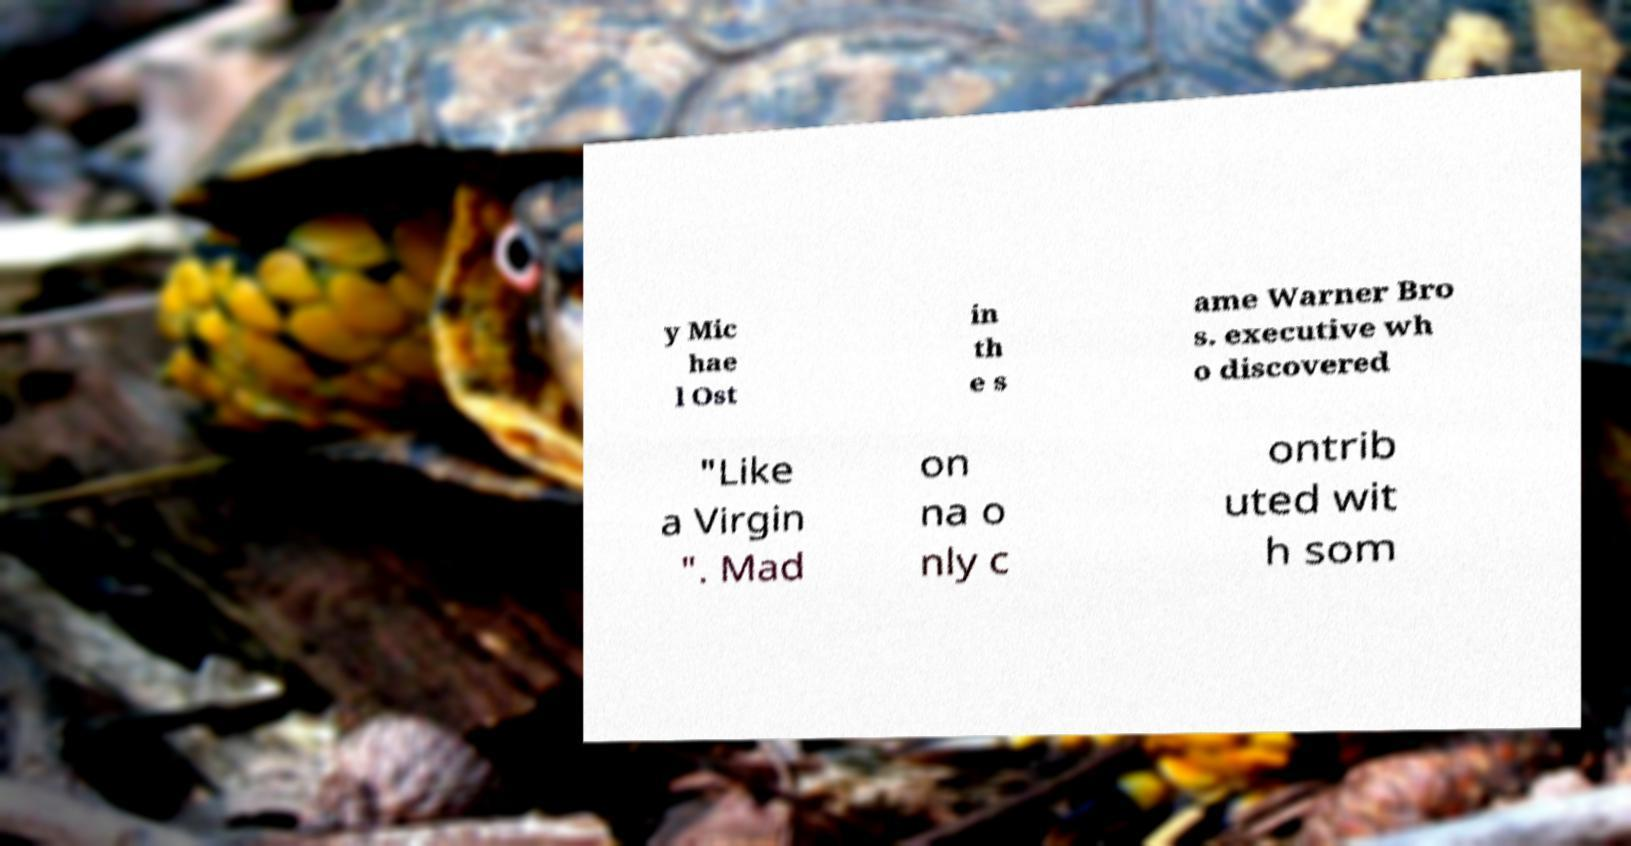What messages or text are displayed in this image? I need them in a readable, typed format. y Mic hae l Ost in th e s ame Warner Bro s. executive wh o discovered "Like a Virgin ". Mad on na o nly c ontrib uted wit h som 